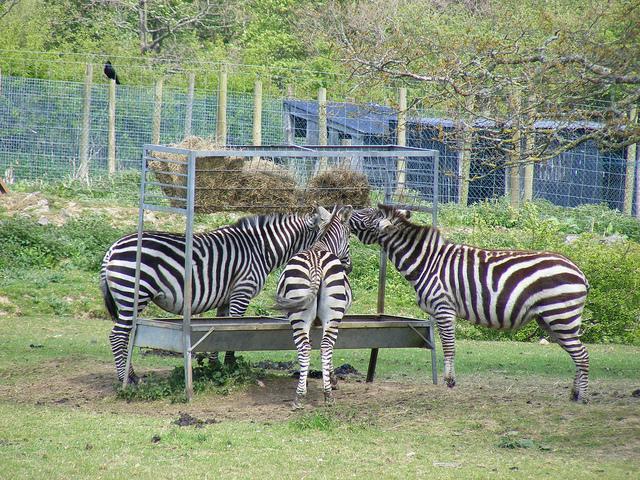How many animals in total?
Give a very brief answer. 3. How many zebras are there?
Give a very brief answer. 3. 